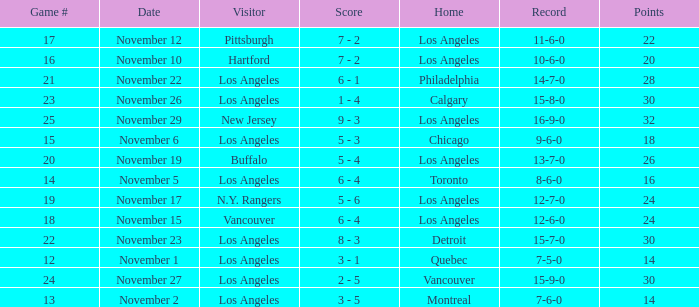What is the record of the game on November 22? 14-7-0. 